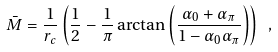<formula> <loc_0><loc_0><loc_500><loc_500>\bar { M } = \frac { 1 } { r _ { c } } \left ( \frac { 1 } { 2 } - \frac { 1 } { \pi } \arctan \left ( \frac { \alpha _ { 0 } + \alpha _ { \pi } } { 1 - \alpha _ { 0 } \alpha _ { \pi } } \right ) \right ) \ ,</formula> 